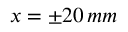Convert formula to latex. <formula><loc_0><loc_0><loc_500><loc_500>x = \pm 2 0 \, m m</formula> 